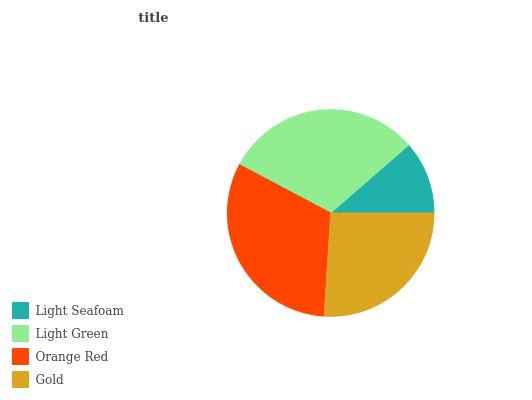Is Light Seafoam the minimum?
Answer yes or no. Yes. Is Orange Red the maximum?
Answer yes or no. Yes. Is Light Green the minimum?
Answer yes or no. No. Is Light Green the maximum?
Answer yes or no. No. Is Light Green greater than Light Seafoam?
Answer yes or no. Yes. Is Light Seafoam less than Light Green?
Answer yes or no. Yes. Is Light Seafoam greater than Light Green?
Answer yes or no. No. Is Light Green less than Light Seafoam?
Answer yes or no. No. Is Light Green the high median?
Answer yes or no. Yes. Is Gold the low median?
Answer yes or no. Yes. Is Gold the high median?
Answer yes or no. No. Is Orange Red the low median?
Answer yes or no. No. 